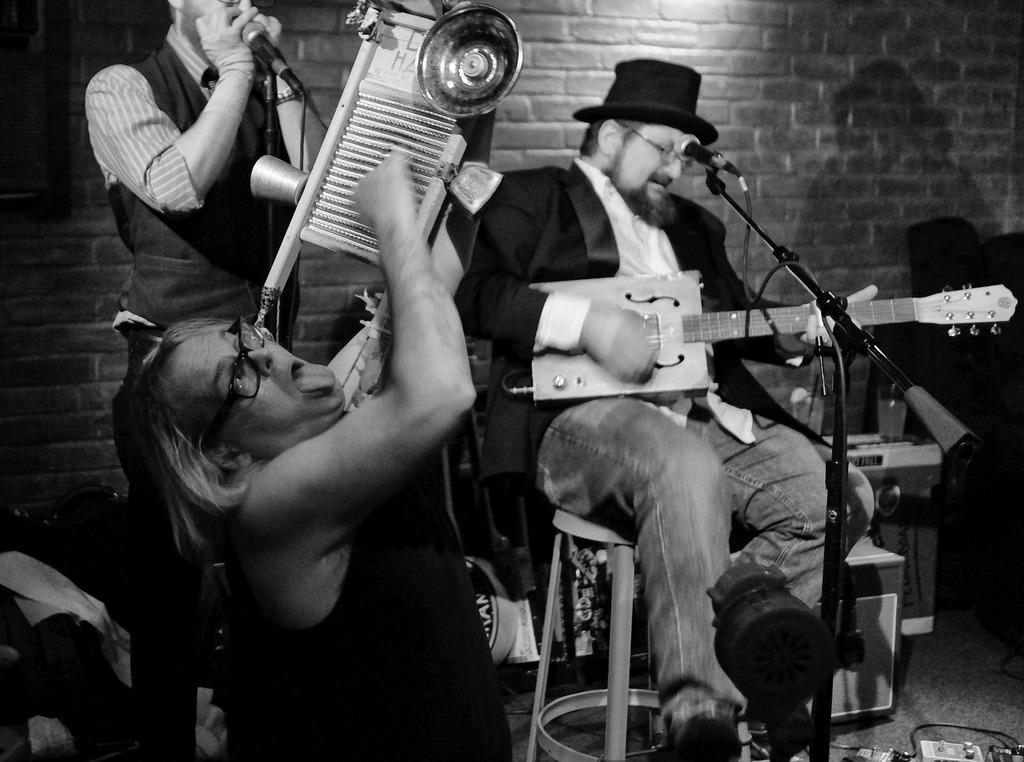What is the color scheme of the image? The image is black and white. Who is present in the image? There is a man in the image. What is the man doing in the image? The man is playing a musical instrument and standing in front of a microphone. What type of chair is the man sitting on? The man is sitting on a chair. What specific musical instrument is the man playing? The man is playing a guitar. Where is the guitar positioned in relation to the microphone? The guitar is in front of a microphone. What type of nerve is present in the image? There is no nerve present in the image; it features a man playing a guitar in front of a microphone. Can you confirm the existence of a substance in the image? The image does not depict any specific substances; it is a black and white image of a man playing a guitar in front of a microphone. 